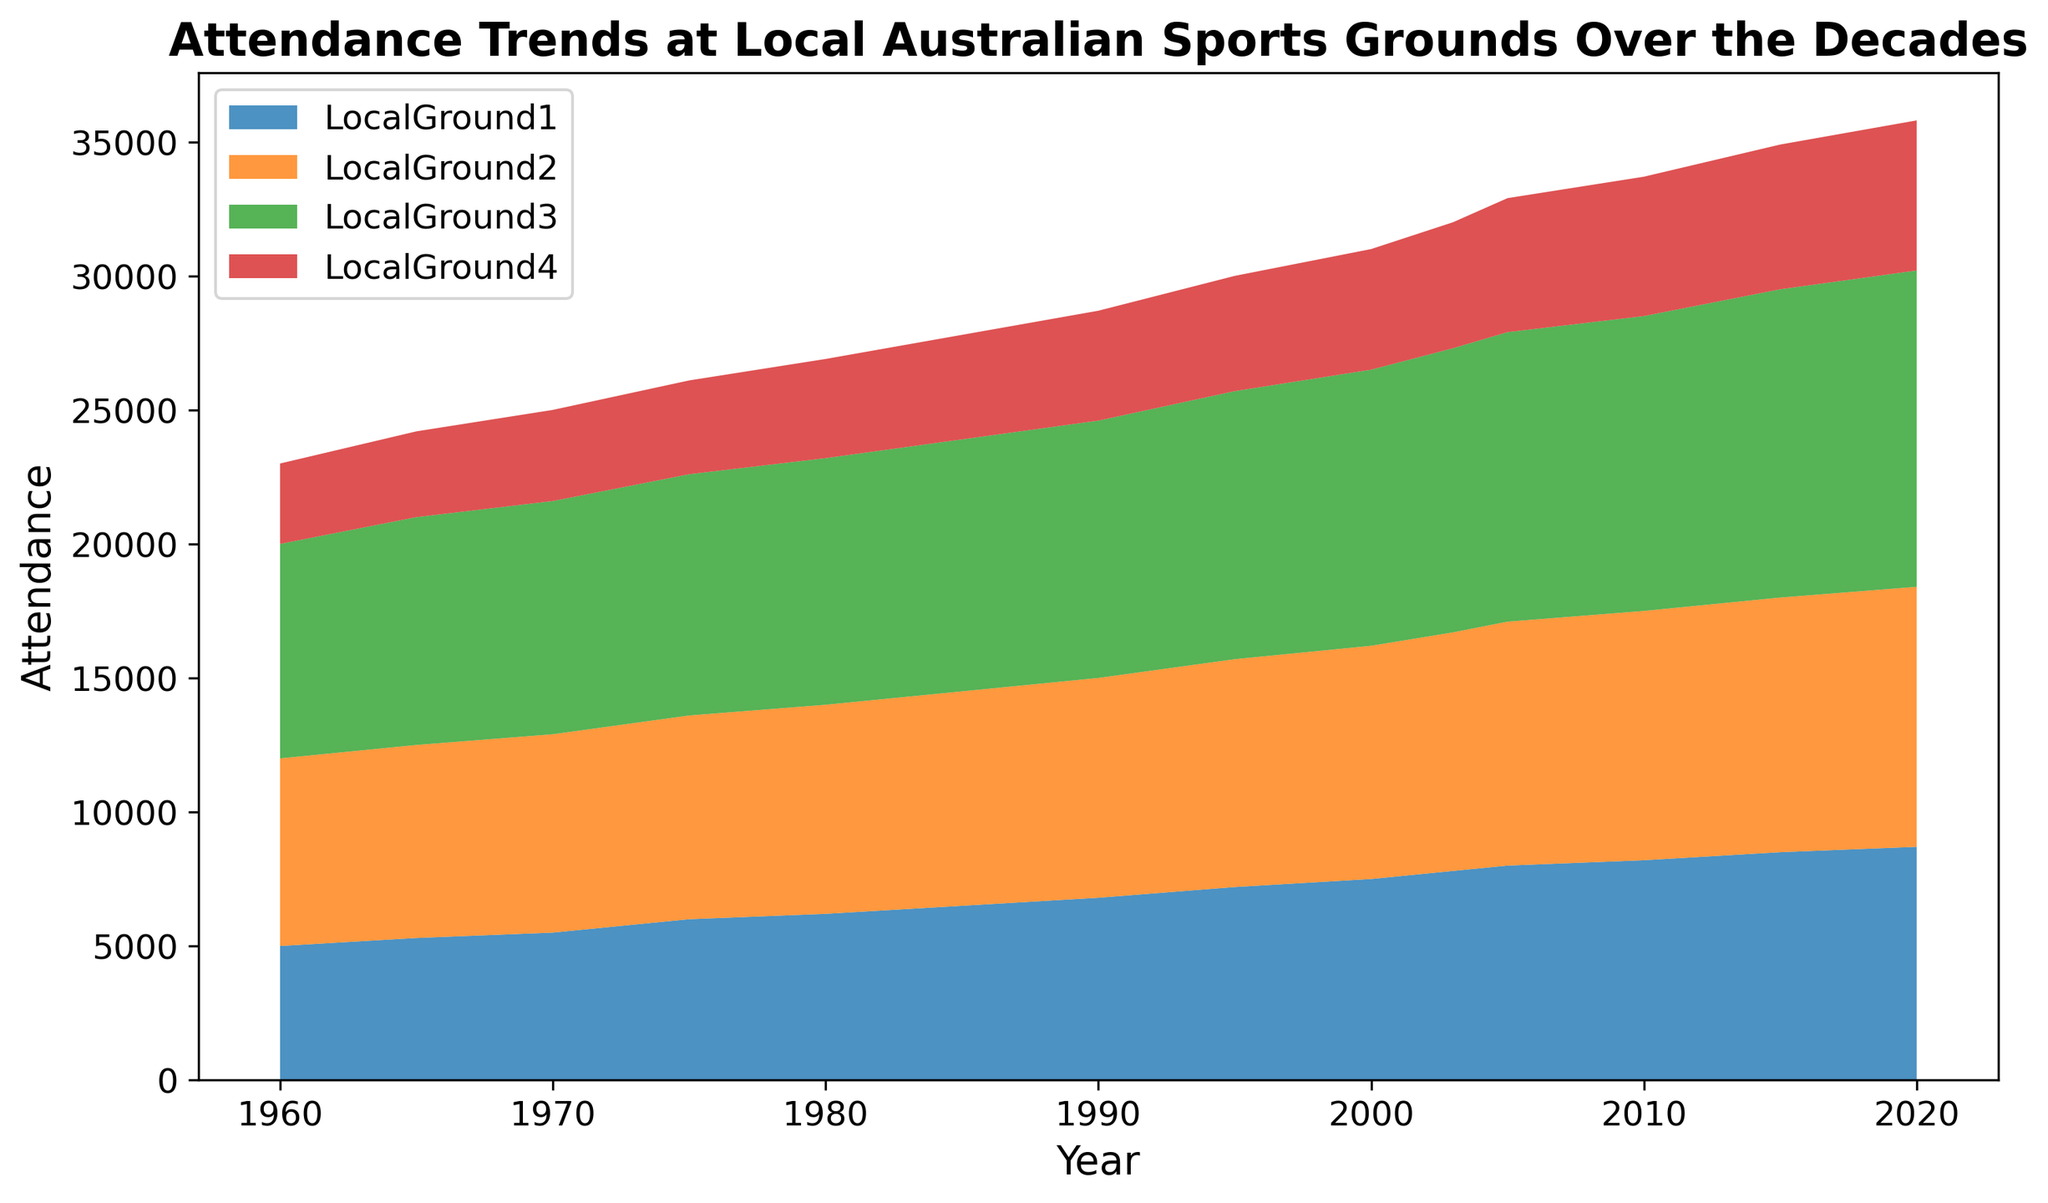Which decade saw the highest increase in attendance for LocalGround1? To find the highest increase, calculate the difference between the attendance in each subsequent decade. Between 1960 and 1970, the increase is 1000; between 1970 and 1980, it is 700; and between 1980 and 1990, it is 600. Therefore, the decade with the highest increase is between 1960 and 1970.
Answer: 1960-1970 Which ground had the highest attendance in the year 2000? Look at the values for each ground in the year 2000. LocalGround1 had 7500, LocalGround2 had 8700, LocalGround3 had 10300, and LocalGround4 had 4500. LocalGround3 had the highest attendance.
Answer: LocalGround3 Compare the attendance at LocalGround2 and LocalGround4 in 1990. Which one had a higher attendance and by how much? In 1990, LocalGround2 had an attendance of 8200, and LocalGround4 had 4100. Subtract LocalGround4's attendance from LocalGround2's attendance (8200 - 4100) to find that LocalGround2 had 4100 more attendees.
Answer: LocalGround2 by 4100 How did the total attendance of all grounds combined change from 1960 to 2020? Add the attendance of all grounds for both years: 1960 (5000+7000+8000+3000 = 23000) and 2020 (8700+9700+11800+5600 = 35800). Then, subtract the total of 1960 from 2020 (35800 - 23000) to find that the change is 12800.
Answer: Increased by 12800 What is the average attendance for LocalGround1 from 1960 to 2020? Sum the attendance values of LocalGround1 for all years provided (5000+5300+5500+6000+6200+6500+6800+7200+7500+7800+8000+8200+8500+8700) = 94200. Divide by the number of years (14), 94200 / 14 = 6728.57.
Answer: 6728.57 Which two grounds had the closest attendance figures in 2010? Look at the values for each ground in 2010: LocalGround1 had 8200, LocalGround2 had 9300, LocalGround3 had 11000, and LocalGround4 had 5200. The closest values are LocalGround1 and LocalGround2. Calculate the absolute difference:
Answer: LocalGround1 and LocalGround2 What was the overall trend in attendance at LocalGround3 over the decades? Observing the values for LocalGround3, attendance consistently increased every decade from 8000 in 1960 to 11800 in 2020. This shows a steady upward trend.
Answer: Steady upward trend Which year did LocalGround2 have the smallest increase in attendance compared to the previous year? Calculate the difference for each period: 1960-1965 (200), 1965-1970 (200), 1970-1975 (200), 1975-1980 (200), 1980-1985 (200), 1985-1990 (200), 1990-1995 (300), 1995-2000 (200), 2000-2003 (200), 2003-2005 (200), 2005-2010 (200), 2010-2015 (200), 2015-2020 (200). All differences are 200 except 1990-1995, which is 300.
Answer: 1960-1985, 2000-2003, 2003-2005, 2005-2010, 2010-2015, 2015-2020 